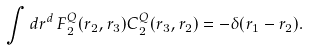Convert formula to latex. <formula><loc_0><loc_0><loc_500><loc_500>\int d r ^ { d } \, F ^ { Q } _ { 2 } ( r _ { 2 } , r _ { 3 } ) C ^ { Q } _ { 2 } ( r _ { 3 } , r _ { 2 } ) = - \delta ( r _ { 1 } - r _ { 2 } ) .</formula> 